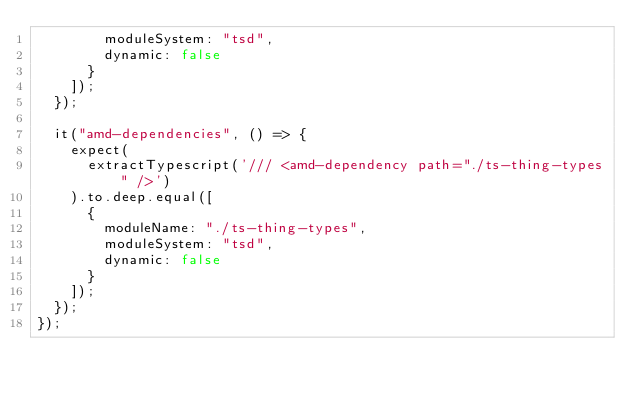<code> <loc_0><loc_0><loc_500><loc_500><_JavaScript_>        moduleSystem: "tsd",
        dynamic: false
      }
    ]);
  });

  it("amd-dependencies", () => {
    expect(
      extractTypescript('/// <amd-dependency path="./ts-thing-types" />')
    ).to.deep.equal([
      {
        moduleName: "./ts-thing-types",
        moduleSystem: "tsd",
        dynamic: false
      }
    ]);
  });
});
</code> 